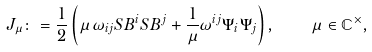Convert formula to latex. <formula><loc_0><loc_0><loc_500><loc_500>J _ { \mu } \colon = \frac { 1 } { 2 } \left ( \mu \, \omega _ { i j } S B ^ { i } S B ^ { j } + \frac { 1 } { \mu } \omega ^ { i j } \Psi _ { i } \Psi _ { j } \right ) , \quad \mu \in \mathbb { C } ^ { \times } ,</formula> 